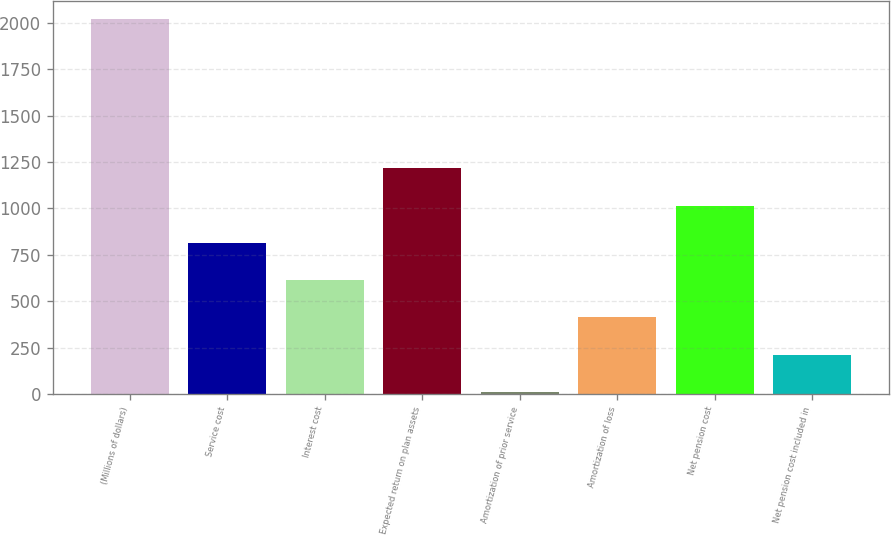Convert chart to OTSL. <chart><loc_0><loc_0><loc_500><loc_500><bar_chart><fcel>(Millions of dollars)<fcel>Service cost<fcel>Interest cost<fcel>Expected return on plan assets<fcel>Amortization of prior service<fcel>Amortization of loss<fcel>Net pension cost<fcel>Net pension cost included in<nl><fcel>2018<fcel>815<fcel>614.5<fcel>1216<fcel>13<fcel>414<fcel>1015.5<fcel>213.5<nl></chart> 